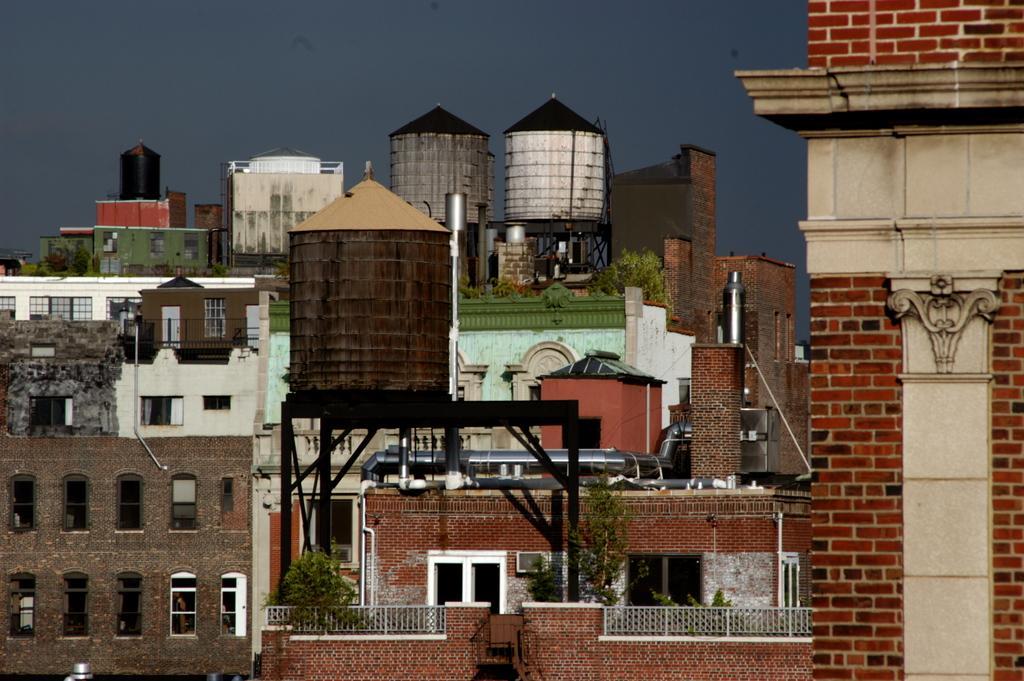Describe this image in one or two sentences. In this image there are buildings and few overhead tanks. 